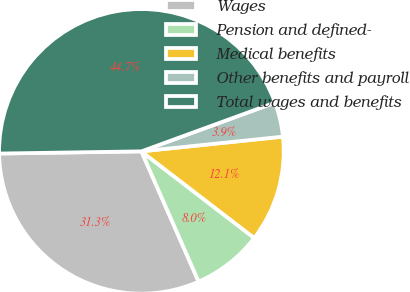<chart> <loc_0><loc_0><loc_500><loc_500><pie_chart><fcel>Wages<fcel>Pension and defined-<fcel>Medical benefits<fcel>Other benefits and payroll<fcel>Total wages and benefits<nl><fcel>31.34%<fcel>7.99%<fcel>12.07%<fcel>3.92%<fcel>44.67%<nl></chart> 